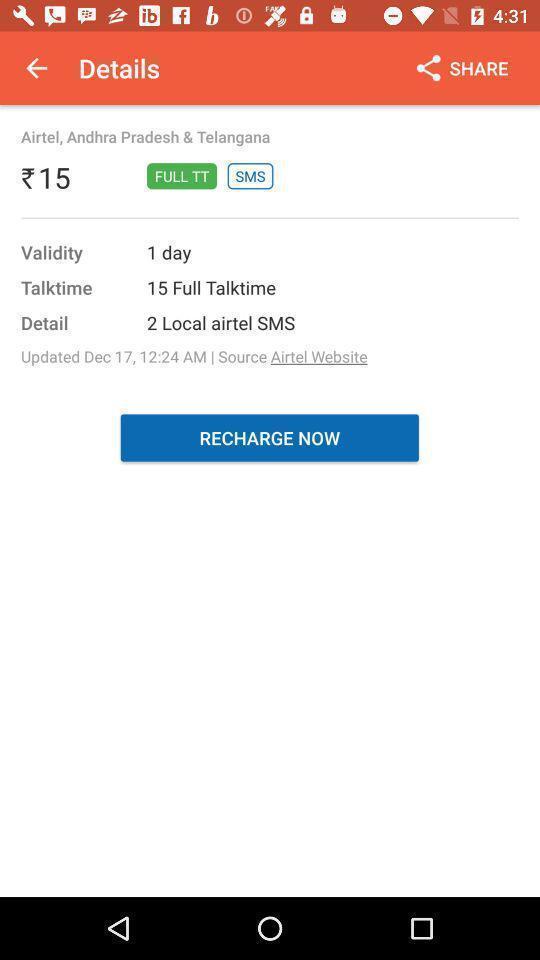Give me a summary of this screen capture. Page displaying the details of talktime plan. 